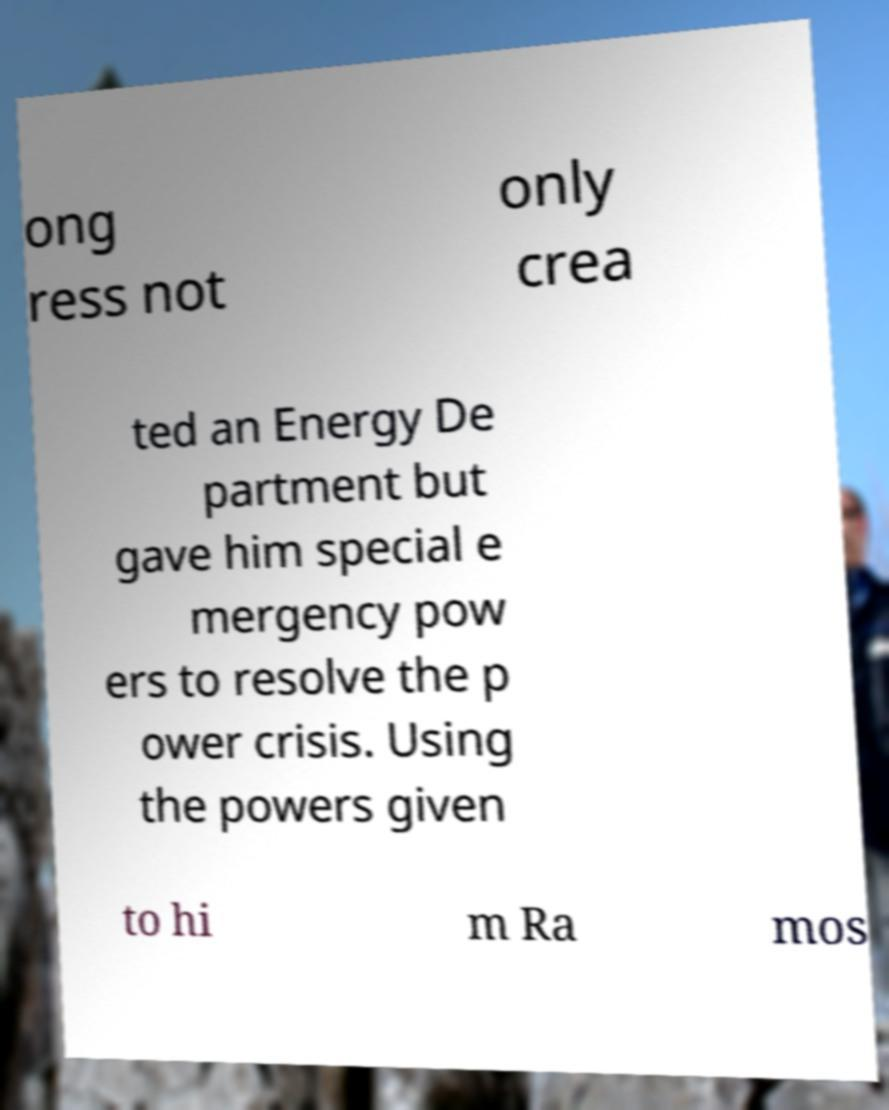For documentation purposes, I need the text within this image transcribed. Could you provide that? ong ress not only crea ted an Energy De partment but gave him special e mergency pow ers to resolve the p ower crisis. Using the powers given to hi m Ra mos 